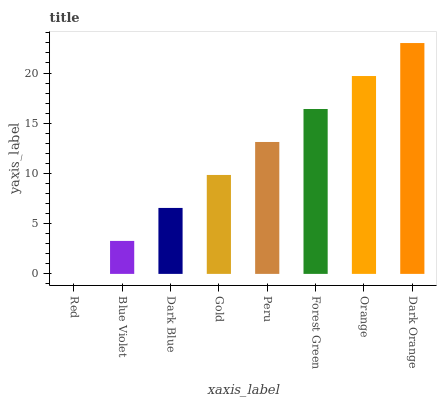Is Red the minimum?
Answer yes or no. Yes. Is Dark Orange the maximum?
Answer yes or no. Yes. Is Blue Violet the minimum?
Answer yes or no. No. Is Blue Violet the maximum?
Answer yes or no. No. Is Blue Violet greater than Red?
Answer yes or no. Yes. Is Red less than Blue Violet?
Answer yes or no. Yes. Is Red greater than Blue Violet?
Answer yes or no. No. Is Blue Violet less than Red?
Answer yes or no. No. Is Peru the high median?
Answer yes or no. Yes. Is Gold the low median?
Answer yes or no. Yes. Is Dark Orange the high median?
Answer yes or no. No. Is Blue Violet the low median?
Answer yes or no. No. 